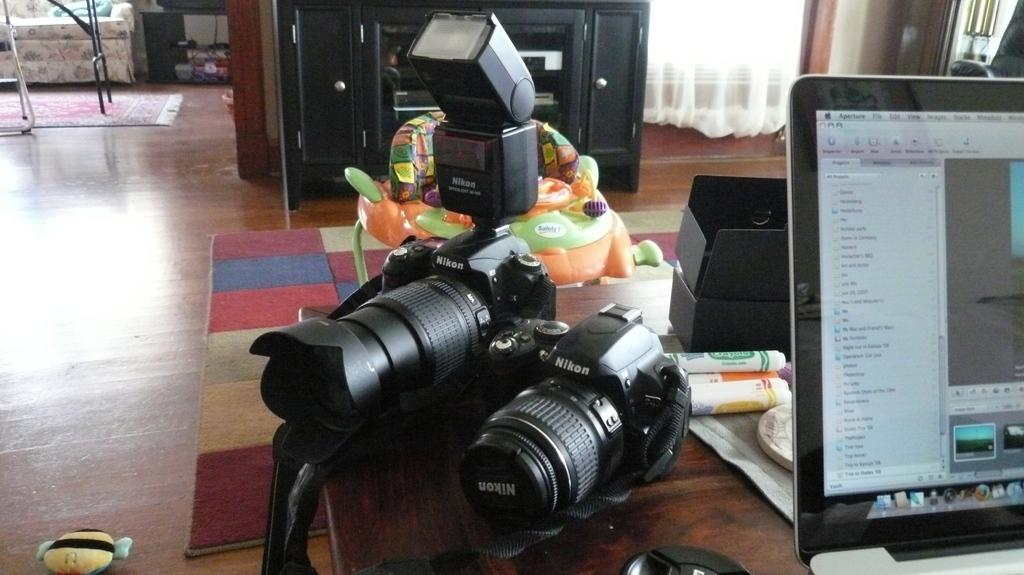How many cameras are visible in the image? There are 2 cameras in the image. What electronic device is also present in the image? There is a laptop in the image. Where are the cameras and laptop located? The cameras and laptop are on a table. What type of flooring is visible in the background of the image? There is a wooden floor in the background of the image. Are there any additional features on the wooden floor? Yes, there are carpets on the wooden floor in the background. What color of paint is being used to show the growth of the plants in the image? There are no plants or paint present in the image; it features cameras, a laptop, and a wooden floor with carpets. 